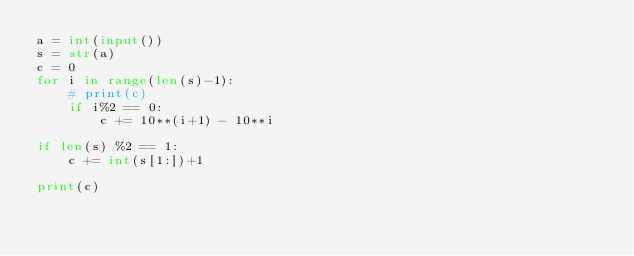<code> <loc_0><loc_0><loc_500><loc_500><_Python_>a = int(input())
s = str(a)
c = 0
for i in range(len(s)-1):
    # print(c)
    if i%2 == 0:
        c += 10**(i+1) - 10**i 

if len(s) %2 == 1:
    c += int(s[1:])+1

print(c)
</code> 